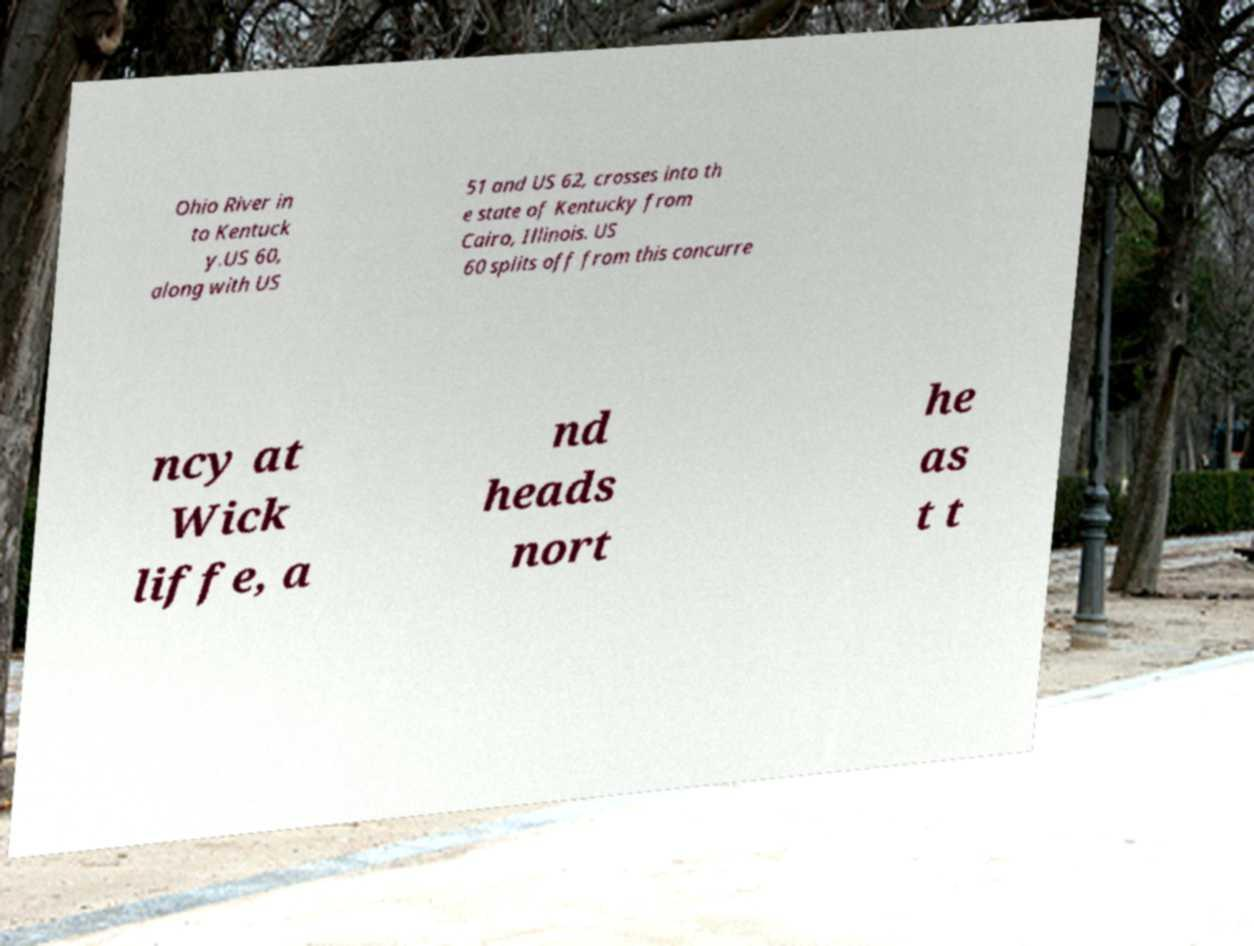Could you assist in decoding the text presented in this image and type it out clearly? Ohio River in to Kentuck y.US 60, along with US 51 and US 62, crosses into th e state of Kentucky from Cairo, Illinois. US 60 splits off from this concurre ncy at Wick liffe, a nd heads nort he as t t 